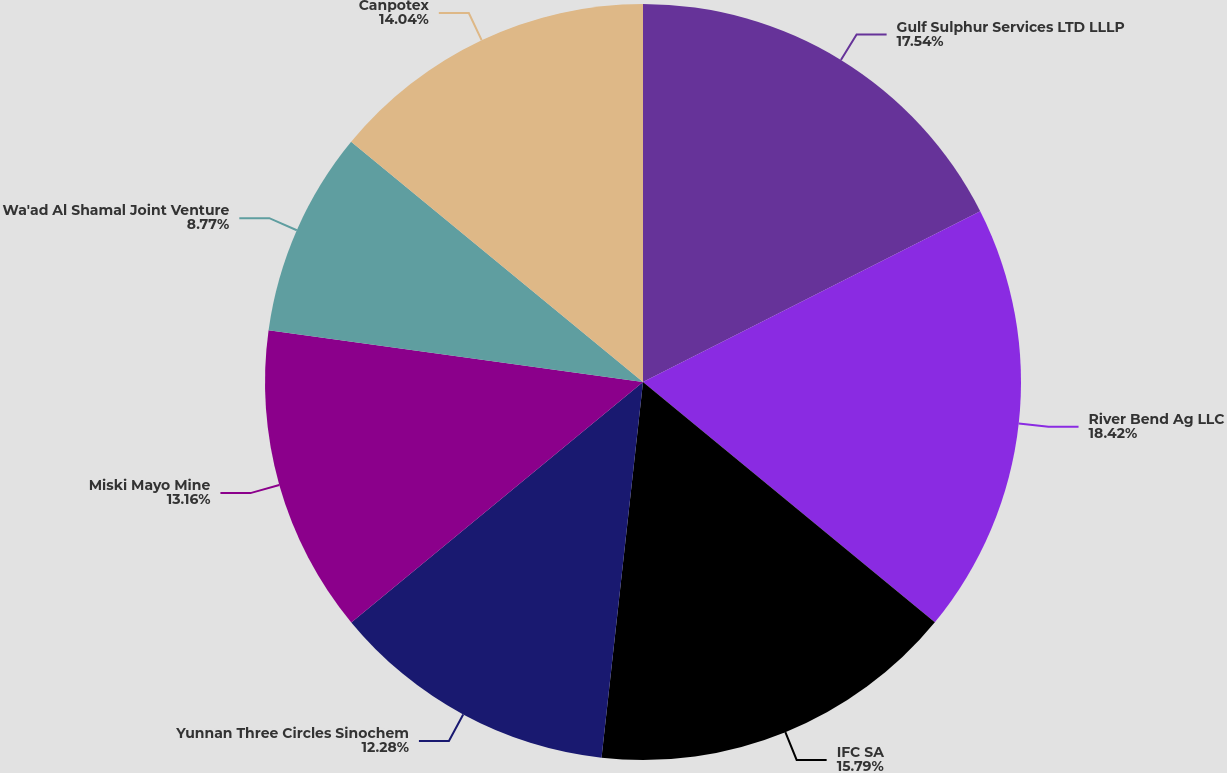Convert chart. <chart><loc_0><loc_0><loc_500><loc_500><pie_chart><fcel>Gulf Sulphur Services LTD LLLP<fcel>River Bend Ag LLC<fcel>IFC SA<fcel>Yunnan Three Circles Sinochem<fcel>Miski Mayo Mine<fcel>Wa'ad Al Shamal Joint Venture<fcel>Canpotex<nl><fcel>17.54%<fcel>18.42%<fcel>15.79%<fcel>12.28%<fcel>13.16%<fcel>8.77%<fcel>14.04%<nl></chart> 